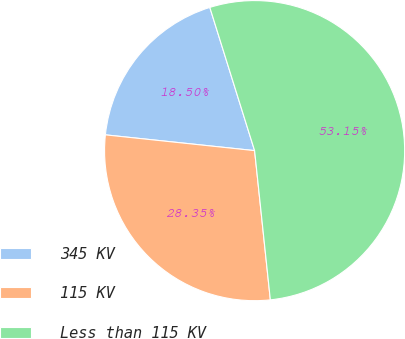Convert chart to OTSL. <chart><loc_0><loc_0><loc_500><loc_500><pie_chart><fcel>345 KV<fcel>115 KV<fcel>Less than 115 KV<nl><fcel>18.5%<fcel>28.35%<fcel>53.15%<nl></chart> 